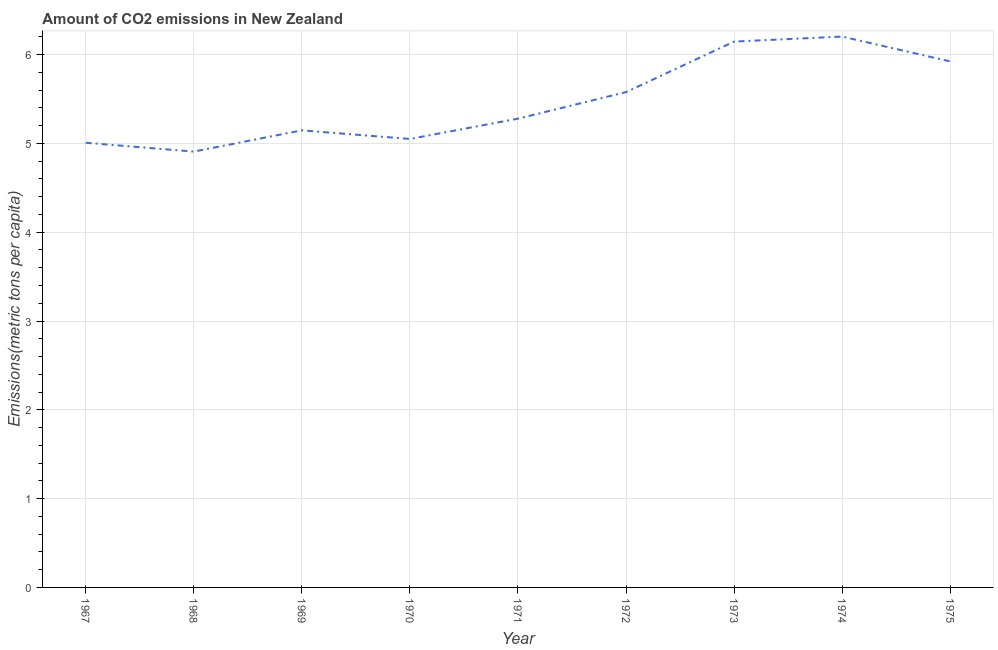What is the amount of co2 emissions in 1974?
Provide a succinct answer. 6.2. Across all years, what is the maximum amount of co2 emissions?
Provide a succinct answer. 6.2. Across all years, what is the minimum amount of co2 emissions?
Your response must be concise. 4.91. In which year was the amount of co2 emissions maximum?
Provide a short and direct response. 1974. In which year was the amount of co2 emissions minimum?
Make the answer very short. 1968. What is the sum of the amount of co2 emissions?
Your answer should be very brief. 49.24. What is the difference between the amount of co2 emissions in 1971 and 1975?
Keep it short and to the point. -0.64. What is the average amount of co2 emissions per year?
Give a very brief answer. 5.47. What is the median amount of co2 emissions?
Offer a terse response. 5.28. In how many years, is the amount of co2 emissions greater than 4 metric tons per capita?
Provide a succinct answer. 9. Do a majority of the years between 1975 and 1970 (inclusive) have amount of co2 emissions greater than 3.6 metric tons per capita?
Provide a succinct answer. Yes. What is the ratio of the amount of co2 emissions in 1968 to that in 1975?
Keep it short and to the point. 0.83. Is the amount of co2 emissions in 1971 less than that in 1973?
Offer a terse response. Yes. Is the difference between the amount of co2 emissions in 1970 and 1973 greater than the difference between any two years?
Give a very brief answer. No. What is the difference between the highest and the second highest amount of co2 emissions?
Provide a short and direct response. 0.06. What is the difference between the highest and the lowest amount of co2 emissions?
Provide a succinct answer. 1.3. In how many years, is the amount of co2 emissions greater than the average amount of co2 emissions taken over all years?
Offer a very short reply. 4. Does the amount of co2 emissions monotonically increase over the years?
Ensure brevity in your answer.  No. How many lines are there?
Ensure brevity in your answer.  1. How many years are there in the graph?
Make the answer very short. 9. Are the values on the major ticks of Y-axis written in scientific E-notation?
Offer a terse response. No. Does the graph contain any zero values?
Your response must be concise. No. What is the title of the graph?
Offer a terse response. Amount of CO2 emissions in New Zealand. What is the label or title of the Y-axis?
Offer a terse response. Emissions(metric tons per capita). What is the Emissions(metric tons per capita) of 1967?
Provide a succinct answer. 5.01. What is the Emissions(metric tons per capita) in 1968?
Provide a short and direct response. 4.91. What is the Emissions(metric tons per capita) of 1969?
Give a very brief answer. 5.15. What is the Emissions(metric tons per capita) of 1970?
Your answer should be compact. 5.05. What is the Emissions(metric tons per capita) of 1971?
Offer a terse response. 5.28. What is the Emissions(metric tons per capita) in 1972?
Ensure brevity in your answer.  5.58. What is the Emissions(metric tons per capita) in 1973?
Your answer should be very brief. 6.15. What is the Emissions(metric tons per capita) of 1974?
Provide a short and direct response. 6.2. What is the Emissions(metric tons per capita) in 1975?
Your answer should be compact. 5.92. What is the difference between the Emissions(metric tons per capita) in 1967 and 1968?
Keep it short and to the point. 0.1. What is the difference between the Emissions(metric tons per capita) in 1967 and 1969?
Your answer should be compact. -0.14. What is the difference between the Emissions(metric tons per capita) in 1967 and 1970?
Make the answer very short. -0.04. What is the difference between the Emissions(metric tons per capita) in 1967 and 1971?
Offer a terse response. -0.27. What is the difference between the Emissions(metric tons per capita) in 1967 and 1972?
Make the answer very short. -0.57. What is the difference between the Emissions(metric tons per capita) in 1967 and 1973?
Provide a short and direct response. -1.14. What is the difference between the Emissions(metric tons per capita) in 1967 and 1974?
Your answer should be compact. -1.2. What is the difference between the Emissions(metric tons per capita) in 1967 and 1975?
Make the answer very short. -0.92. What is the difference between the Emissions(metric tons per capita) in 1968 and 1969?
Offer a terse response. -0.24. What is the difference between the Emissions(metric tons per capita) in 1968 and 1970?
Your response must be concise. -0.14. What is the difference between the Emissions(metric tons per capita) in 1968 and 1971?
Your answer should be compact. -0.37. What is the difference between the Emissions(metric tons per capita) in 1968 and 1972?
Ensure brevity in your answer.  -0.67. What is the difference between the Emissions(metric tons per capita) in 1968 and 1973?
Provide a succinct answer. -1.24. What is the difference between the Emissions(metric tons per capita) in 1968 and 1974?
Your answer should be very brief. -1.3. What is the difference between the Emissions(metric tons per capita) in 1968 and 1975?
Your response must be concise. -1.02. What is the difference between the Emissions(metric tons per capita) in 1969 and 1970?
Offer a terse response. 0.1. What is the difference between the Emissions(metric tons per capita) in 1969 and 1971?
Offer a terse response. -0.13. What is the difference between the Emissions(metric tons per capita) in 1969 and 1972?
Keep it short and to the point. -0.43. What is the difference between the Emissions(metric tons per capita) in 1969 and 1973?
Provide a succinct answer. -1. What is the difference between the Emissions(metric tons per capita) in 1969 and 1974?
Your answer should be very brief. -1.06. What is the difference between the Emissions(metric tons per capita) in 1969 and 1975?
Your answer should be compact. -0.78. What is the difference between the Emissions(metric tons per capita) in 1970 and 1971?
Provide a succinct answer. -0.23. What is the difference between the Emissions(metric tons per capita) in 1970 and 1972?
Your response must be concise. -0.53. What is the difference between the Emissions(metric tons per capita) in 1970 and 1973?
Make the answer very short. -1.1. What is the difference between the Emissions(metric tons per capita) in 1970 and 1974?
Your answer should be compact. -1.15. What is the difference between the Emissions(metric tons per capita) in 1970 and 1975?
Offer a very short reply. -0.87. What is the difference between the Emissions(metric tons per capita) in 1971 and 1972?
Provide a succinct answer. -0.3. What is the difference between the Emissions(metric tons per capita) in 1971 and 1973?
Make the answer very short. -0.87. What is the difference between the Emissions(metric tons per capita) in 1971 and 1974?
Your response must be concise. -0.92. What is the difference between the Emissions(metric tons per capita) in 1971 and 1975?
Your answer should be very brief. -0.64. What is the difference between the Emissions(metric tons per capita) in 1972 and 1973?
Offer a terse response. -0.57. What is the difference between the Emissions(metric tons per capita) in 1972 and 1974?
Give a very brief answer. -0.63. What is the difference between the Emissions(metric tons per capita) in 1972 and 1975?
Offer a very short reply. -0.35. What is the difference between the Emissions(metric tons per capita) in 1973 and 1974?
Offer a very short reply. -0.06. What is the difference between the Emissions(metric tons per capita) in 1973 and 1975?
Provide a short and direct response. 0.22. What is the difference between the Emissions(metric tons per capita) in 1974 and 1975?
Provide a short and direct response. 0.28. What is the ratio of the Emissions(metric tons per capita) in 1967 to that in 1968?
Offer a terse response. 1.02. What is the ratio of the Emissions(metric tons per capita) in 1967 to that in 1971?
Offer a very short reply. 0.95. What is the ratio of the Emissions(metric tons per capita) in 1967 to that in 1972?
Keep it short and to the point. 0.9. What is the ratio of the Emissions(metric tons per capita) in 1967 to that in 1973?
Give a very brief answer. 0.81. What is the ratio of the Emissions(metric tons per capita) in 1967 to that in 1974?
Provide a short and direct response. 0.81. What is the ratio of the Emissions(metric tons per capita) in 1967 to that in 1975?
Offer a very short reply. 0.84. What is the ratio of the Emissions(metric tons per capita) in 1968 to that in 1969?
Your answer should be compact. 0.95. What is the ratio of the Emissions(metric tons per capita) in 1968 to that in 1970?
Offer a terse response. 0.97. What is the ratio of the Emissions(metric tons per capita) in 1968 to that in 1972?
Your response must be concise. 0.88. What is the ratio of the Emissions(metric tons per capita) in 1968 to that in 1973?
Provide a succinct answer. 0.8. What is the ratio of the Emissions(metric tons per capita) in 1968 to that in 1974?
Ensure brevity in your answer.  0.79. What is the ratio of the Emissions(metric tons per capita) in 1968 to that in 1975?
Provide a short and direct response. 0.83. What is the ratio of the Emissions(metric tons per capita) in 1969 to that in 1972?
Provide a succinct answer. 0.92. What is the ratio of the Emissions(metric tons per capita) in 1969 to that in 1973?
Your answer should be compact. 0.84. What is the ratio of the Emissions(metric tons per capita) in 1969 to that in 1974?
Your answer should be very brief. 0.83. What is the ratio of the Emissions(metric tons per capita) in 1969 to that in 1975?
Offer a terse response. 0.87. What is the ratio of the Emissions(metric tons per capita) in 1970 to that in 1971?
Offer a very short reply. 0.96. What is the ratio of the Emissions(metric tons per capita) in 1970 to that in 1972?
Offer a terse response. 0.91. What is the ratio of the Emissions(metric tons per capita) in 1970 to that in 1973?
Offer a very short reply. 0.82. What is the ratio of the Emissions(metric tons per capita) in 1970 to that in 1974?
Provide a short and direct response. 0.81. What is the ratio of the Emissions(metric tons per capita) in 1970 to that in 1975?
Ensure brevity in your answer.  0.85. What is the ratio of the Emissions(metric tons per capita) in 1971 to that in 1972?
Your answer should be very brief. 0.95. What is the ratio of the Emissions(metric tons per capita) in 1971 to that in 1973?
Your answer should be very brief. 0.86. What is the ratio of the Emissions(metric tons per capita) in 1971 to that in 1974?
Make the answer very short. 0.85. What is the ratio of the Emissions(metric tons per capita) in 1971 to that in 1975?
Your response must be concise. 0.89. What is the ratio of the Emissions(metric tons per capita) in 1972 to that in 1973?
Offer a terse response. 0.91. What is the ratio of the Emissions(metric tons per capita) in 1972 to that in 1974?
Give a very brief answer. 0.9. What is the ratio of the Emissions(metric tons per capita) in 1972 to that in 1975?
Ensure brevity in your answer.  0.94. What is the ratio of the Emissions(metric tons per capita) in 1973 to that in 1974?
Keep it short and to the point. 0.99. What is the ratio of the Emissions(metric tons per capita) in 1973 to that in 1975?
Provide a short and direct response. 1.04. What is the ratio of the Emissions(metric tons per capita) in 1974 to that in 1975?
Offer a very short reply. 1.05. 